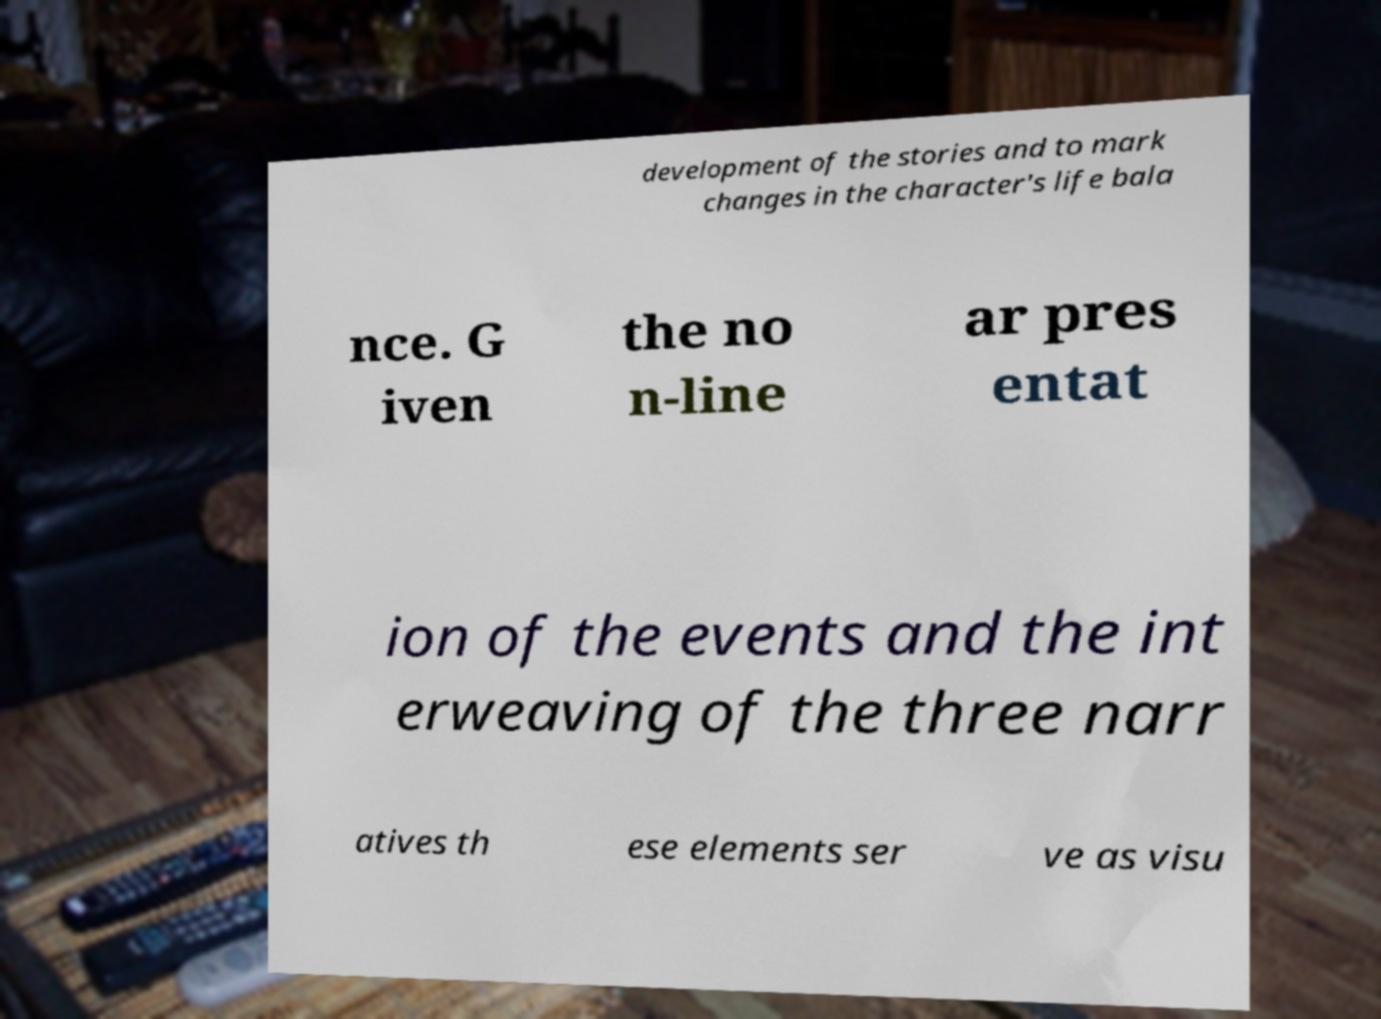Can you accurately transcribe the text from the provided image for me? development of the stories and to mark changes in the character's life bala nce. G iven the no n-line ar pres entat ion of the events and the int erweaving of the three narr atives th ese elements ser ve as visu 